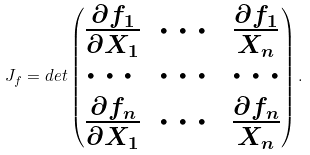<formula> <loc_0><loc_0><loc_500><loc_500>J _ { f } = d e t \begin{pmatrix} \frac { \partial f _ { 1 } } { \partial X _ { 1 } } & \cdots & \frac { \partial f _ { 1 } } { X _ { n } } \\ \cdots & \cdots & \cdots \\ \frac { \partial f _ { n } } { \partial X _ { 1 } } & \cdots & \frac { \partial f _ { n } } { X _ { n } } \end{pmatrix} .</formula> 